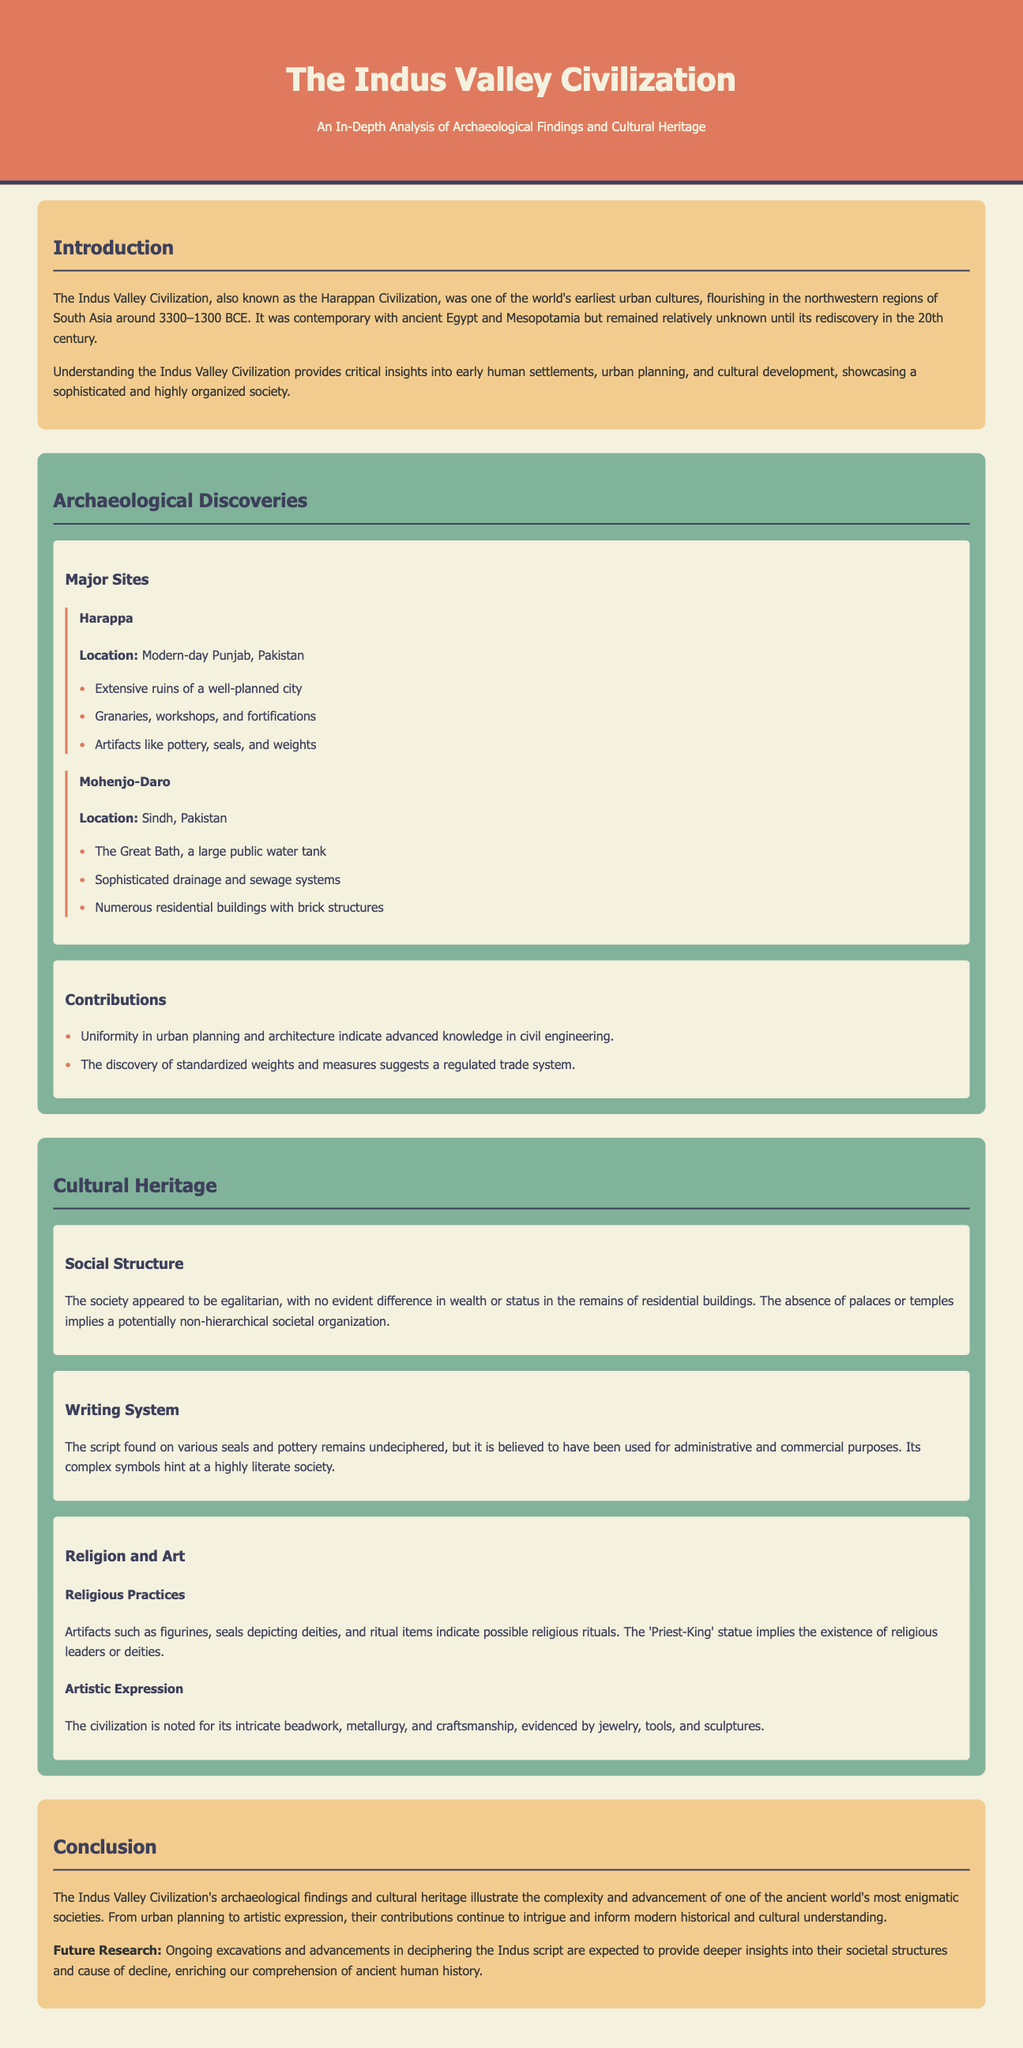What is the other name for the Indus Valley Civilization? The Indus Valley Civilization is also known as the Harappan Civilization.
Answer: Harappan Civilization What time period did the Indus Valley Civilization flourish? The document states that the civilization flourished around 3300–1300 BCE.
Answer: 3300–1300 BCE Which two ancient civilizations were contemporary with the Indus Valley Civilization? The document mentions that it was contemporary with ancient Egypt and Mesopotamia.
Answer: Ancient Egypt and Mesopotamia What significant feature was found at Mohenjo-Daro? The document highlights The Great Bath as a significant feature at Mohenjo-Daro.
Answer: The Great Bath What type of social structure did the Indus Valley Civilization demonstrate? The document describes the society as appearing to be egalitarian, indicating a non-hierarchical organization.
Answer: Egalitarian What does the undeciphered script suggests about the society? The script's complexity hints at a highly literate society, as indicated in the document.
Answer: Highly literate What artifacts indicate possible religious practices? Artifacts such as figurines, seals depicting deities, and ritual items suggest possible religious rituals.
Answer: Figurines, seals, ritual items What is the expected future research focus mentioned in the conclusion? The conclusion notes that future research will focus on ongoing excavations and advancements in deciphering the Indus script.
Answer: Ongoing excavations and deciphering the Indus script What is one of the notable artistic expressions of the civilization? The civilization is noted for its intricate beadwork and craftsmanship, as mentioned in the document.
Answer: Intricate beadwork and craftsmanship 